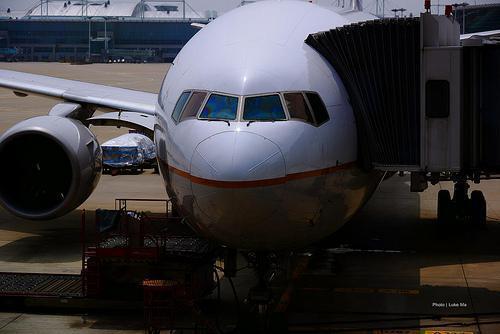How many planes are there?
Give a very brief answer. 1. 